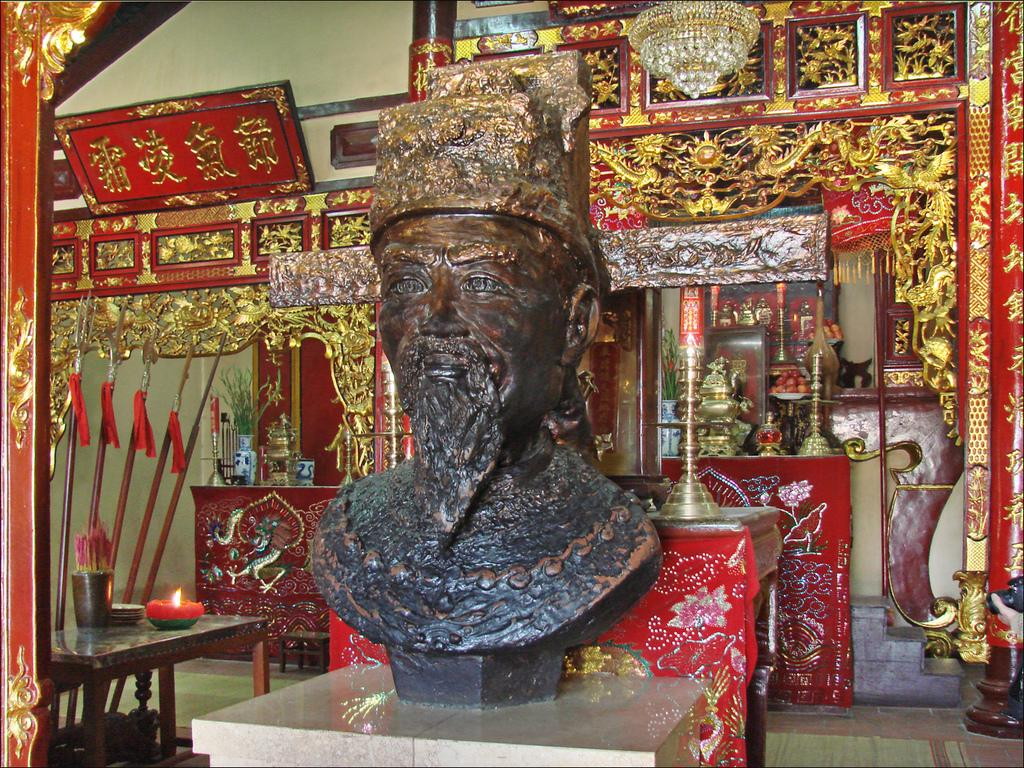What is located on the surface in the image? There is a statue on the surface in the image. What type of object can be seen in the image besides the statue? There is an earthenware object in the image. What is present on the table in the image? There are objects on the table in the image. What is visible in the background of the image? There is a board in the background, and there are objects on the table in the background. What part of the room can be seen in the image? The floor is visible in the image. Can you tell me how many horses are fighting near the statue in the image? There are no horses or fighting depicted in the image; it features a statue and an earthenware object on a surface, with objects on a table in the background. 